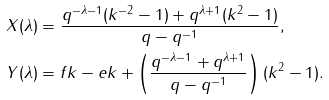Convert formula to latex. <formula><loc_0><loc_0><loc_500><loc_500>X ( \lambda ) & = \frac { q ^ { - \lambda - 1 } ( k ^ { - 2 } - 1 ) + q ^ { \lambda + 1 } ( k ^ { 2 } - 1 ) } { q - q ^ { - 1 } } , \\ Y ( \lambda ) & = f k - e k + \left ( \frac { q ^ { - \lambda - 1 } + q ^ { \lambda + 1 } } { q - q ^ { - 1 } } \right ) ( k ^ { 2 } - 1 ) .</formula> 